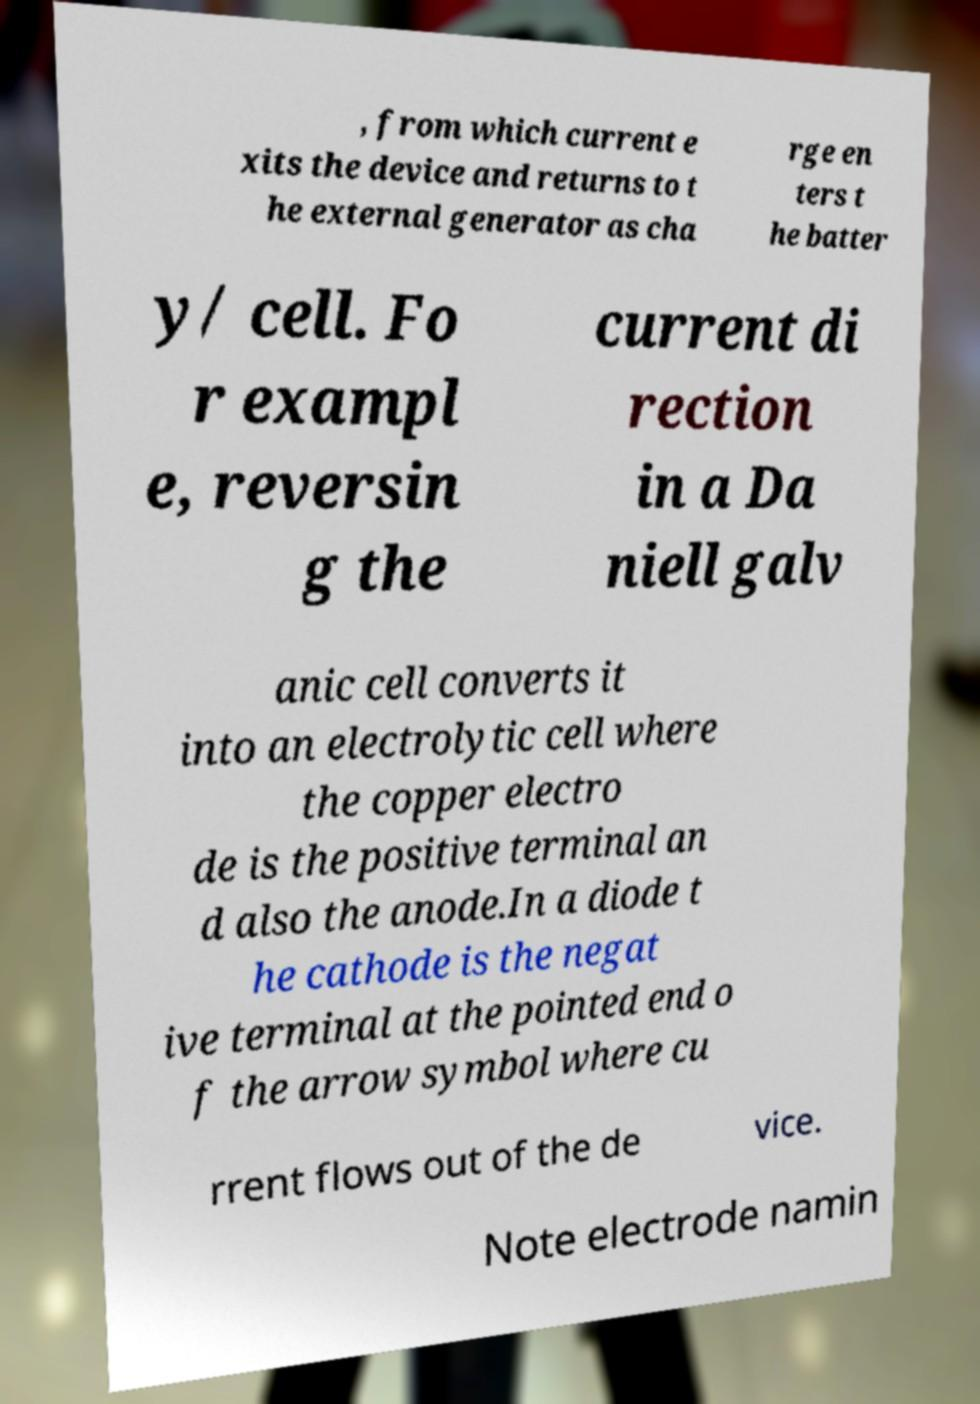Please identify and transcribe the text found in this image. , from which current e xits the device and returns to t he external generator as cha rge en ters t he batter y/ cell. Fo r exampl e, reversin g the current di rection in a Da niell galv anic cell converts it into an electrolytic cell where the copper electro de is the positive terminal an d also the anode.In a diode t he cathode is the negat ive terminal at the pointed end o f the arrow symbol where cu rrent flows out of the de vice. Note electrode namin 